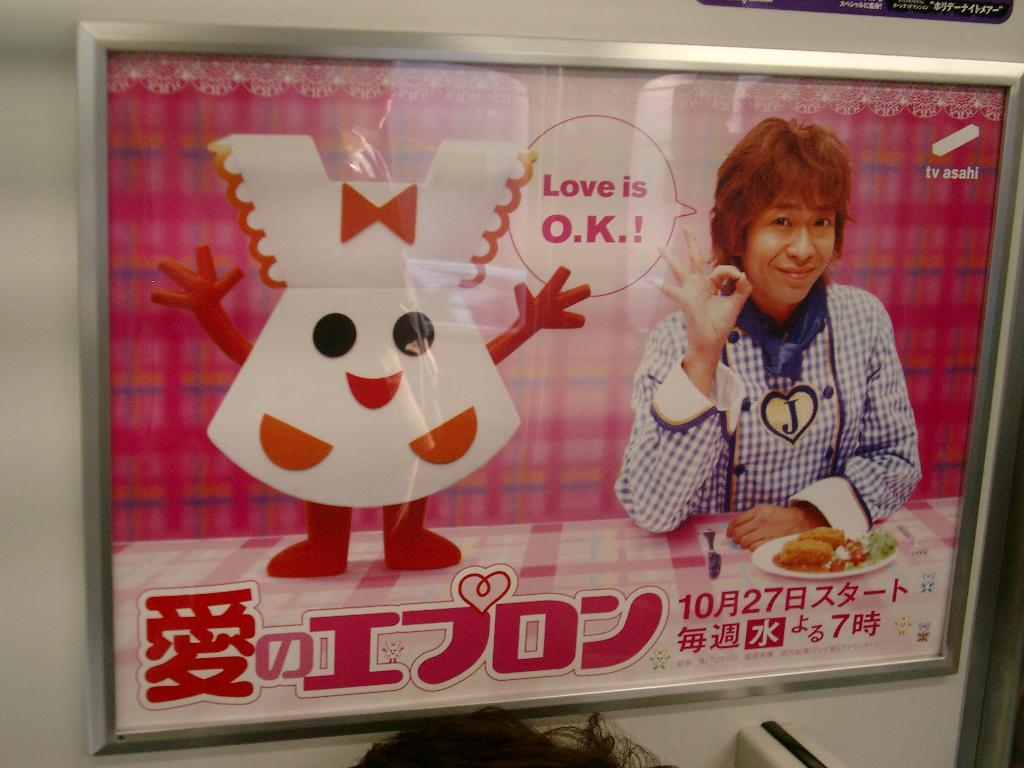What is the main subject of the image? The main subject of the image is a photo frame of a person. What else can be seen in the image? There is a plate containing food in the image. Can you describe the text on the plate? Unfortunately, the text on the plate cannot be described without more information about its content. How many bottles are visible in the image? There are no bottles present in the image. What type of letter is being pushed by the person in the photo frame? There is no person visible in the image, as it only shows a photo frame of a person. 